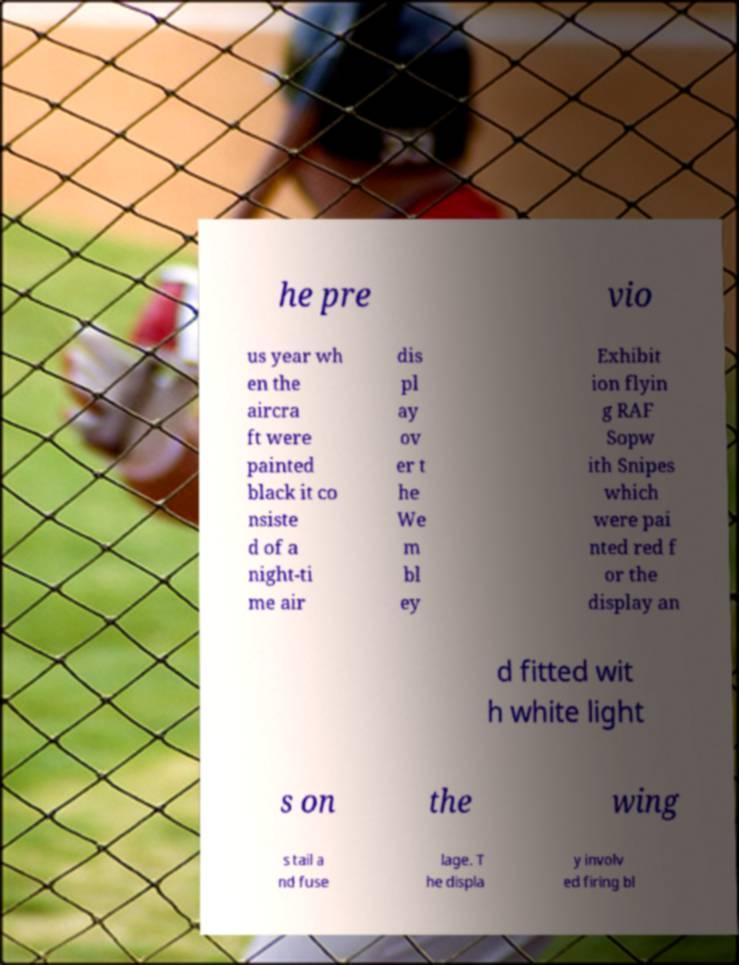I need the written content from this picture converted into text. Can you do that? he pre vio us year wh en the aircra ft were painted black it co nsiste d of a night-ti me air dis pl ay ov er t he We m bl ey Exhibit ion flyin g RAF Sopw ith Snipes which were pai nted red f or the display an d fitted wit h white light s on the wing s tail a nd fuse lage. T he displa y involv ed firing bl 